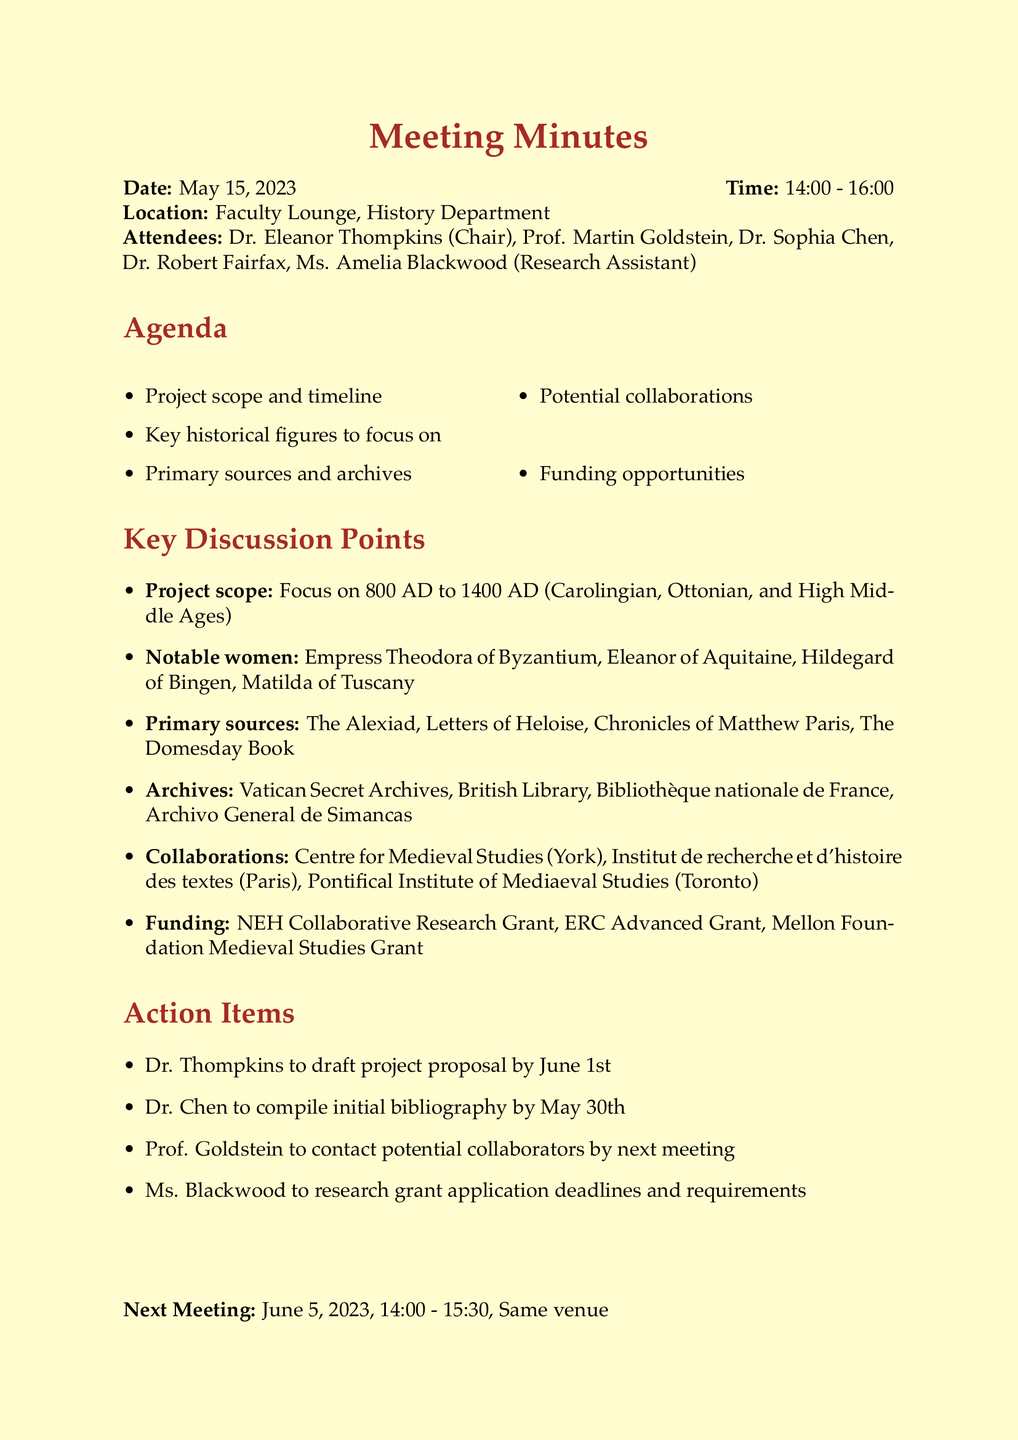What is the date of the meeting? The date of the meeting is stated at the beginning of the document.
Answer: May 15, 2023 Who is the chair of the meeting? The chair is mentioned in the attendees section of the document.
Answer: Dr. Eleanor Thompkins What is the time duration of the meeting? The duration is given in the meeting details and is the difference between the start and end times.
Answer: 2 hours Which archive is listed as the first to visit? The first archive is mentioned in the archives section of the document.
Answer: Vatican Secret Archives What is the focus period of the project? The project scope details the specific period under study in the document.
Answer: 800 AD to 1400 AD Which notable woman is associated with the High Middle Ages? The notable women are listed, and reasoning involves identifying relevance to the High Middle Ages.
Answer: Eleanor of Aquitaine What is one funding opportunity mentioned? The funding opportunities section lists several grants available for the project.
Answer: NEH Collaborative Research Grant When is the next meeting scheduled? The next meeting's date is clearly outlined in the document.
Answer: June 5, 2023 